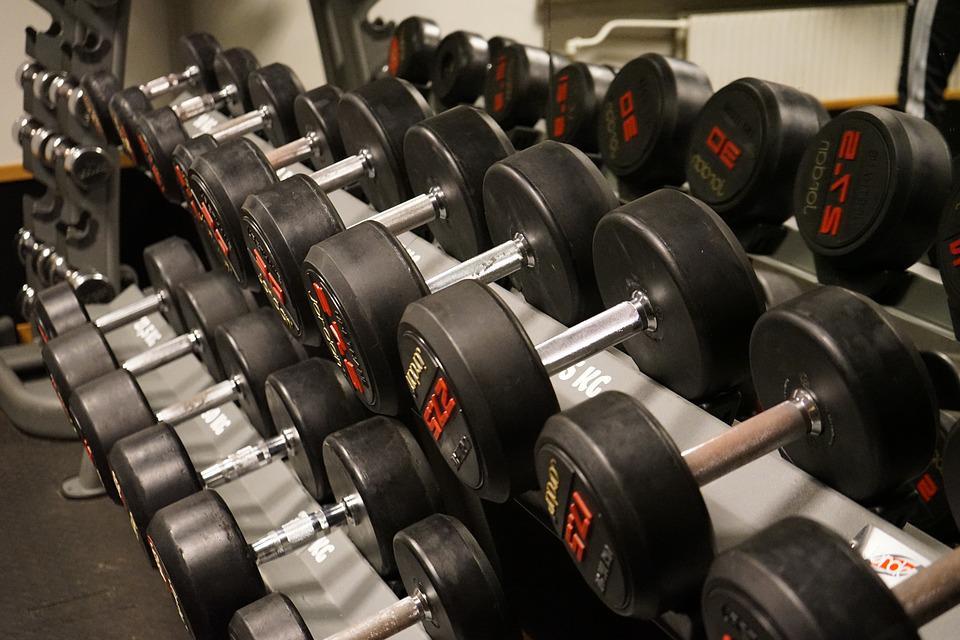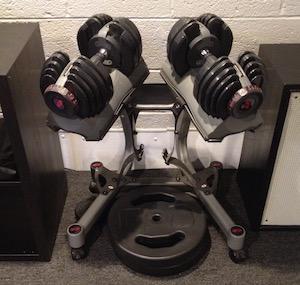The first image is the image on the left, the second image is the image on the right. Assess this claim about the two images: "In at least one image there is a single hand adjusting a red and black weight.". Correct or not? Answer yes or no. No. 